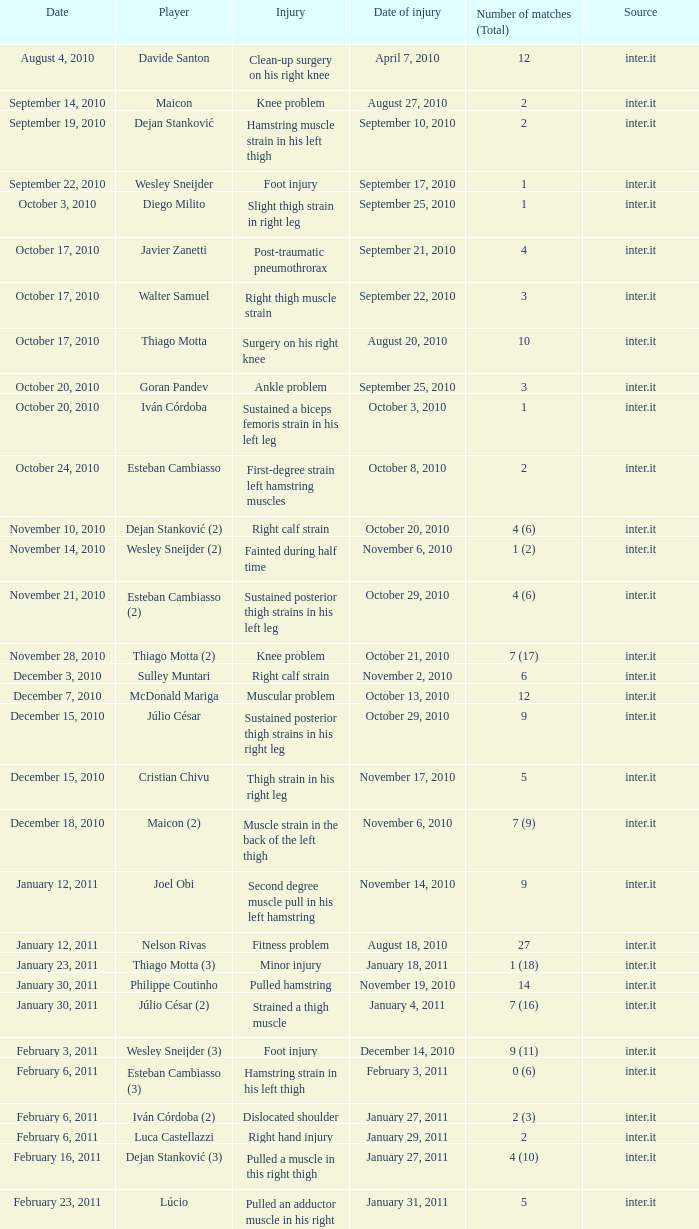What is the date of injury for player Wesley sneijder (2)? November 6, 2010. 